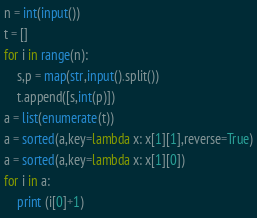Convert code to text. <code><loc_0><loc_0><loc_500><loc_500><_Python_>n = int(input())
t = []
for i in range(n):
	s,p = map(str,input().split())
	t.append([s,int(p)])
a = list(enumerate(t))
a = sorted(a,key=lambda x: x[1][1],reverse=True)
a = sorted(a,key=lambda x: x[1][0])
for i in a:
	print (i[0]+1)</code> 